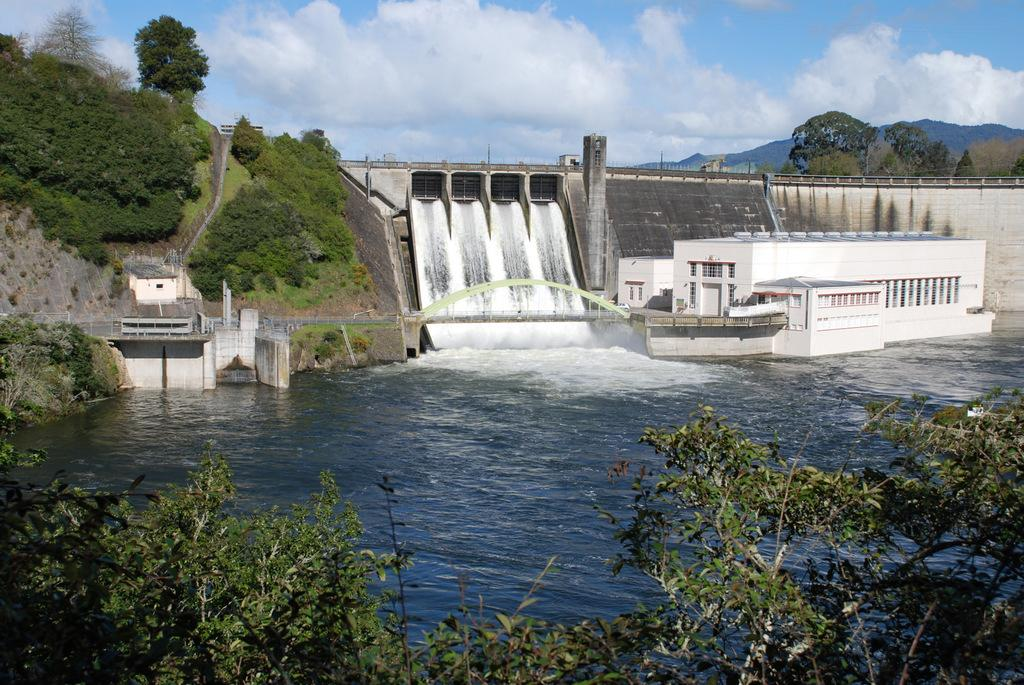What type of living organisms can be seen in the image? Plants and trees are visible in the image. What natural element can be seen in the image? Water is visible in the image. What type of structure can be seen in the image? There is a storage house, a dam, and a bridge in the image. What type of terrain is visible in the image? Hills are visible in the image. What is the color of the sky in the background of the image? The sky is blue in the background of the image. What can be seen in the sky in the image? Clouds are visible in the sky in the image. How many chickens are sitting on the bridge in the image? There are no chickens present in the image. What type of sponge is floating in the water in the image? There is no sponge visible in the image. 